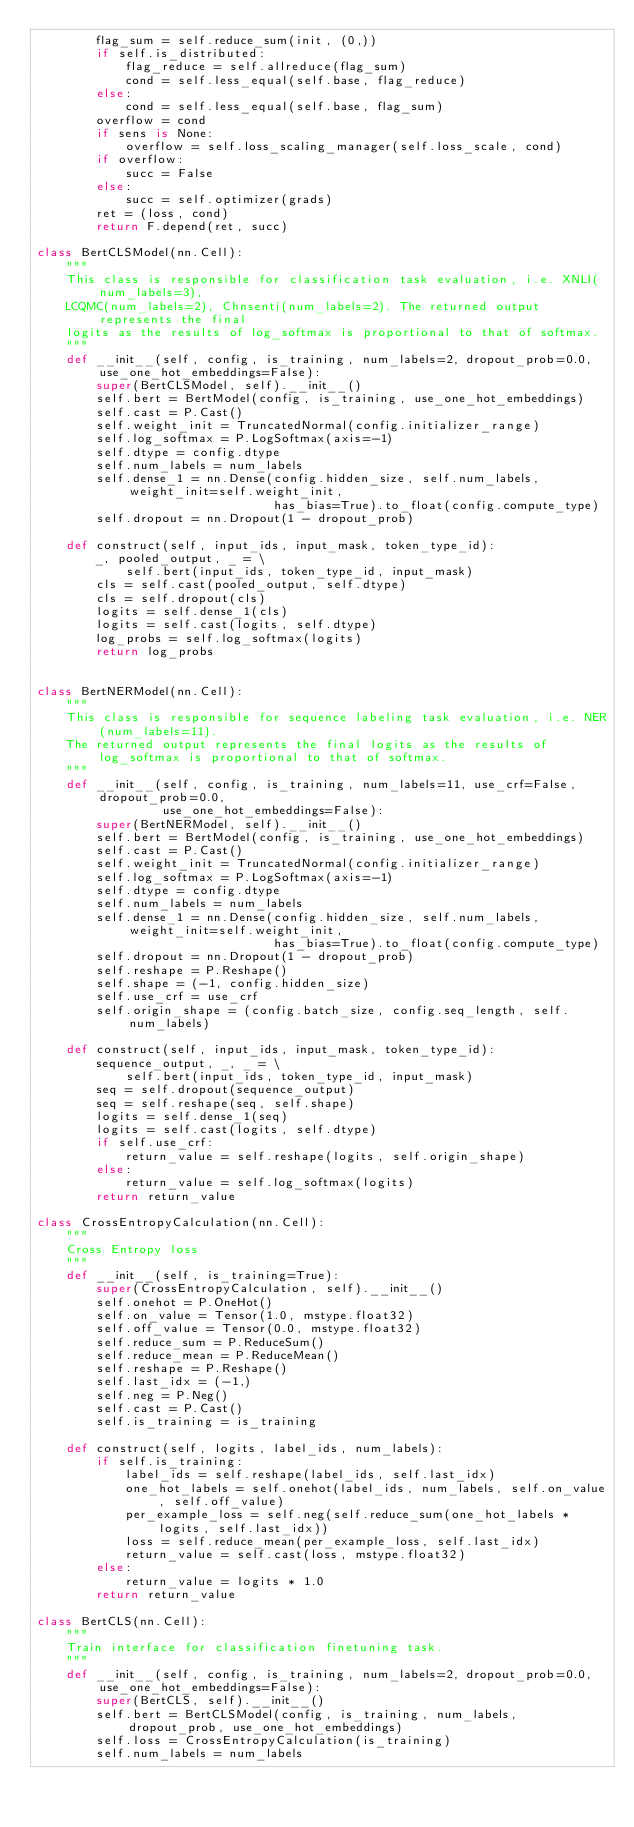<code> <loc_0><loc_0><loc_500><loc_500><_Python_>        flag_sum = self.reduce_sum(init, (0,))
        if self.is_distributed:
            flag_reduce = self.allreduce(flag_sum)
            cond = self.less_equal(self.base, flag_reduce)
        else:
            cond = self.less_equal(self.base, flag_sum)
        overflow = cond
        if sens is None:
            overflow = self.loss_scaling_manager(self.loss_scale, cond)
        if overflow:
            succ = False
        else:
            succ = self.optimizer(grads)
        ret = (loss, cond)
        return F.depend(ret, succ)

class BertCLSModel(nn.Cell):
    """
    This class is responsible for classification task evaluation, i.e. XNLI(num_labels=3),
    LCQMC(num_labels=2), Chnsenti(num_labels=2). The returned output represents the final
    logits as the results of log_softmax is proportional to that of softmax.
    """
    def __init__(self, config, is_training, num_labels=2, dropout_prob=0.0, use_one_hot_embeddings=False):
        super(BertCLSModel, self).__init__()
        self.bert = BertModel(config, is_training, use_one_hot_embeddings)
        self.cast = P.Cast()
        self.weight_init = TruncatedNormal(config.initializer_range)
        self.log_softmax = P.LogSoftmax(axis=-1)
        self.dtype = config.dtype
        self.num_labels = num_labels
        self.dense_1 = nn.Dense(config.hidden_size, self.num_labels, weight_init=self.weight_init,
                                has_bias=True).to_float(config.compute_type)
        self.dropout = nn.Dropout(1 - dropout_prob)

    def construct(self, input_ids, input_mask, token_type_id):
        _, pooled_output, _ = \
            self.bert(input_ids, token_type_id, input_mask)
        cls = self.cast(pooled_output, self.dtype)
        cls = self.dropout(cls)
        logits = self.dense_1(cls)
        logits = self.cast(logits, self.dtype)
        log_probs = self.log_softmax(logits)
        return log_probs


class BertNERModel(nn.Cell):
    """
    This class is responsible for sequence labeling task evaluation, i.e. NER(num_labels=11).
    The returned output represents the final logits as the results of log_softmax is proportional to that of softmax.
    """
    def __init__(self, config, is_training, num_labels=11, use_crf=False, dropout_prob=0.0,
                 use_one_hot_embeddings=False):
        super(BertNERModel, self).__init__()
        self.bert = BertModel(config, is_training, use_one_hot_embeddings)
        self.cast = P.Cast()
        self.weight_init = TruncatedNormal(config.initializer_range)
        self.log_softmax = P.LogSoftmax(axis=-1)
        self.dtype = config.dtype
        self.num_labels = num_labels
        self.dense_1 = nn.Dense(config.hidden_size, self.num_labels, weight_init=self.weight_init,
                                has_bias=True).to_float(config.compute_type)
        self.dropout = nn.Dropout(1 - dropout_prob)
        self.reshape = P.Reshape()
        self.shape = (-1, config.hidden_size)
        self.use_crf = use_crf
        self.origin_shape = (config.batch_size, config.seq_length, self.num_labels)

    def construct(self, input_ids, input_mask, token_type_id):
        sequence_output, _, _ = \
            self.bert(input_ids, token_type_id, input_mask)
        seq = self.dropout(sequence_output)
        seq = self.reshape(seq, self.shape)
        logits = self.dense_1(seq)
        logits = self.cast(logits, self.dtype)
        if self.use_crf:
            return_value = self.reshape(logits, self.origin_shape)
        else:
            return_value = self.log_softmax(logits)
        return return_value

class CrossEntropyCalculation(nn.Cell):
    """
    Cross Entropy loss
    """
    def __init__(self, is_training=True):
        super(CrossEntropyCalculation, self).__init__()
        self.onehot = P.OneHot()
        self.on_value = Tensor(1.0, mstype.float32)
        self.off_value = Tensor(0.0, mstype.float32)
        self.reduce_sum = P.ReduceSum()
        self.reduce_mean = P.ReduceMean()
        self.reshape = P.Reshape()
        self.last_idx = (-1,)
        self.neg = P.Neg()
        self.cast = P.Cast()
        self.is_training = is_training

    def construct(self, logits, label_ids, num_labels):
        if self.is_training:
            label_ids = self.reshape(label_ids, self.last_idx)
            one_hot_labels = self.onehot(label_ids, num_labels, self.on_value, self.off_value)
            per_example_loss = self.neg(self.reduce_sum(one_hot_labels * logits, self.last_idx))
            loss = self.reduce_mean(per_example_loss, self.last_idx)
            return_value = self.cast(loss, mstype.float32)
        else:
            return_value = logits * 1.0
        return return_value

class BertCLS(nn.Cell):
    """
    Train interface for classification finetuning task.
    """
    def __init__(self, config, is_training, num_labels=2, dropout_prob=0.0, use_one_hot_embeddings=False):
        super(BertCLS, self).__init__()
        self.bert = BertCLSModel(config, is_training, num_labels, dropout_prob, use_one_hot_embeddings)
        self.loss = CrossEntropyCalculation(is_training)
        self.num_labels = num_labels</code> 